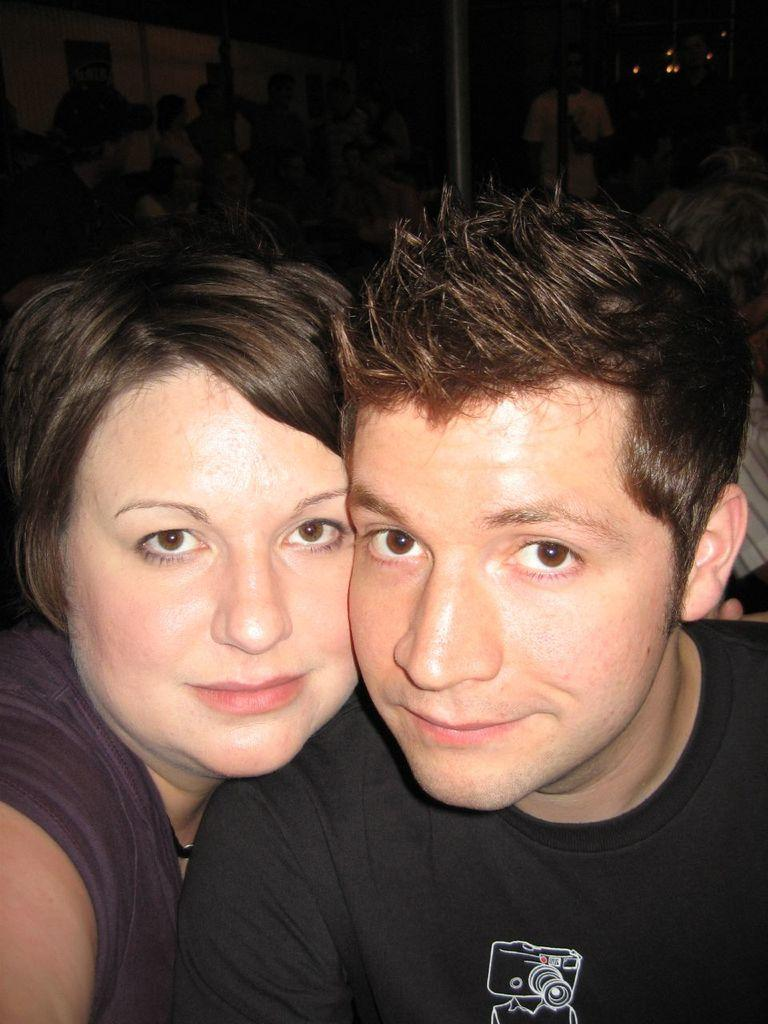Who or what can be seen in the center of the image? There are two people in the center of the image. What is located in the background of the image? There is a pole in the background of the image. Are there any other people visible in the image? Yes, there are people standing in the background of the image. What type of drum can be seen in the hands of the person on the left? There is no drum visible in the image; only two people and a pole in the background are present. 